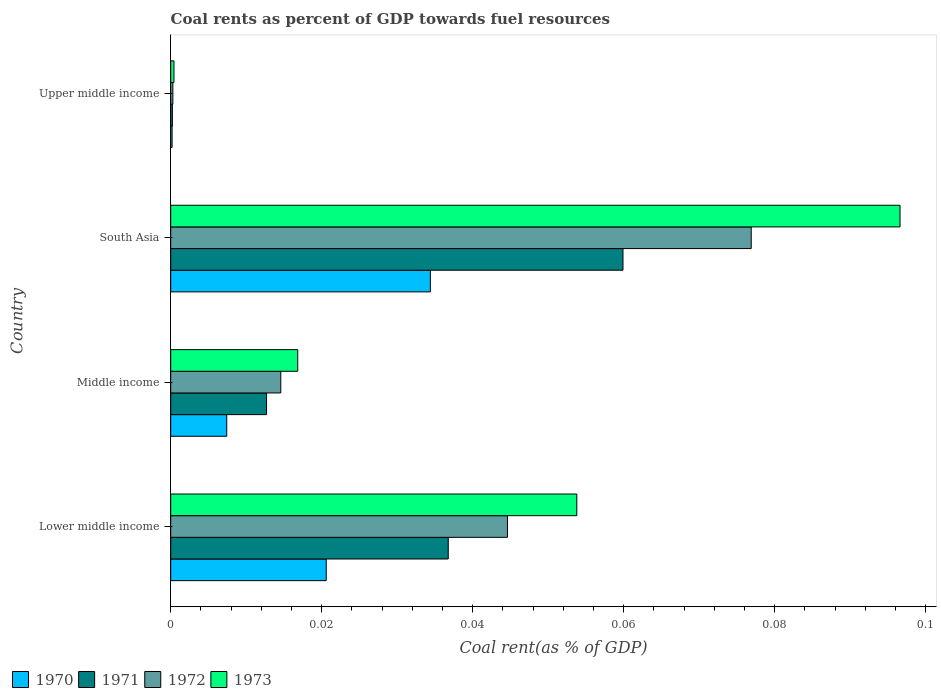How many different coloured bars are there?
Your answer should be compact. 4. What is the label of the 4th group of bars from the top?
Offer a terse response. Lower middle income. What is the coal rent in 1971 in Lower middle income?
Keep it short and to the point. 0.04. Across all countries, what is the maximum coal rent in 1971?
Your answer should be compact. 0.06. Across all countries, what is the minimum coal rent in 1971?
Ensure brevity in your answer.  0. In which country was the coal rent in 1970 minimum?
Give a very brief answer. Upper middle income. What is the total coal rent in 1973 in the graph?
Keep it short and to the point. 0.17. What is the difference between the coal rent in 1971 in Middle income and that in Upper middle income?
Offer a very short reply. 0.01. What is the difference between the coal rent in 1970 in Lower middle income and the coal rent in 1972 in Middle income?
Provide a short and direct response. 0.01. What is the average coal rent in 1972 per country?
Offer a very short reply. 0.03. What is the difference between the coal rent in 1973 and coal rent in 1971 in Middle income?
Offer a terse response. 0. What is the ratio of the coal rent in 1970 in Lower middle income to that in South Asia?
Give a very brief answer. 0.6. What is the difference between the highest and the second highest coal rent in 1972?
Give a very brief answer. 0.03. What is the difference between the highest and the lowest coal rent in 1970?
Provide a succinct answer. 0.03. In how many countries, is the coal rent in 1973 greater than the average coal rent in 1973 taken over all countries?
Give a very brief answer. 2. Is it the case that in every country, the sum of the coal rent in 1973 and coal rent in 1970 is greater than the sum of coal rent in 1971 and coal rent in 1972?
Offer a very short reply. No. What does the 2nd bar from the bottom in Lower middle income represents?
Offer a terse response. 1971. Are all the bars in the graph horizontal?
Your answer should be very brief. Yes. How many countries are there in the graph?
Make the answer very short. 4. Are the values on the major ticks of X-axis written in scientific E-notation?
Ensure brevity in your answer.  No. Does the graph contain any zero values?
Provide a short and direct response. No. Does the graph contain grids?
Keep it short and to the point. No. How many legend labels are there?
Make the answer very short. 4. What is the title of the graph?
Give a very brief answer. Coal rents as percent of GDP towards fuel resources. What is the label or title of the X-axis?
Make the answer very short. Coal rent(as % of GDP). What is the Coal rent(as % of GDP) of 1970 in Lower middle income?
Offer a very short reply. 0.02. What is the Coal rent(as % of GDP) in 1971 in Lower middle income?
Offer a very short reply. 0.04. What is the Coal rent(as % of GDP) in 1972 in Lower middle income?
Offer a terse response. 0.04. What is the Coal rent(as % of GDP) of 1973 in Lower middle income?
Your answer should be compact. 0.05. What is the Coal rent(as % of GDP) of 1970 in Middle income?
Give a very brief answer. 0.01. What is the Coal rent(as % of GDP) of 1971 in Middle income?
Provide a succinct answer. 0.01. What is the Coal rent(as % of GDP) in 1972 in Middle income?
Keep it short and to the point. 0.01. What is the Coal rent(as % of GDP) of 1973 in Middle income?
Ensure brevity in your answer.  0.02. What is the Coal rent(as % of GDP) of 1970 in South Asia?
Give a very brief answer. 0.03. What is the Coal rent(as % of GDP) in 1971 in South Asia?
Your response must be concise. 0.06. What is the Coal rent(as % of GDP) in 1972 in South Asia?
Offer a terse response. 0.08. What is the Coal rent(as % of GDP) in 1973 in South Asia?
Ensure brevity in your answer.  0.1. What is the Coal rent(as % of GDP) in 1970 in Upper middle income?
Ensure brevity in your answer.  0. What is the Coal rent(as % of GDP) of 1971 in Upper middle income?
Provide a short and direct response. 0. What is the Coal rent(as % of GDP) in 1972 in Upper middle income?
Provide a short and direct response. 0. What is the Coal rent(as % of GDP) in 1973 in Upper middle income?
Ensure brevity in your answer.  0. Across all countries, what is the maximum Coal rent(as % of GDP) in 1970?
Offer a terse response. 0.03. Across all countries, what is the maximum Coal rent(as % of GDP) in 1971?
Offer a very short reply. 0.06. Across all countries, what is the maximum Coal rent(as % of GDP) in 1972?
Make the answer very short. 0.08. Across all countries, what is the maximum Coal rent(as % of GDP) in 1973?
Provide a short and direct response. 0.1. Across all countries, what is the minimum Coal rent(as % of GDP) of 1970?
Your response must be concise. 0. Across all countries, what is the minimum Coal rent(as % of GDP) in 1971?
Provide a succinct answer. 0. Across all countries, what is the minimum Coal rent(as % of GDP) in 1972?
Your answer should be compact. 0. Across all countries, what is the minimum Coal rent(as % of GDP) in 1973?
Make the answer very short. 0. What is the total Coal rent(as % of GDP) of 1970 in the graph?
Offer a terse response. 0.06. What is the total Coal rent(as % of GDP) in 1971 in the graph?
Offer a terse response. 0.11. What is the total Coal rent(as % of GDP) of 1972 in the graph?
Offer a very short reply. 0.14. What is the total Coal rent(as % of GDP) of 1973 in the graph?
Give a very brief answer. 0.17. What is the difference between the Coal rent(as % of GDP) in 1970 in Lower middle income and that in Middle income?
Give a very brief answer. 0.01. What is the difference between the Coal rent(as % of GDP) in 1971 in Lower middle income and that in Middle income?
Offer a very short reply. 0.02. What is the difference between the Coal rent(as % of GDP) in 1973 in Lower middle income and that in Middle income?
Keep it short and to the point. 0.04. What is the difference between the Coal rent(as % of GDP) in 1970 in Lower middle income and that in South Asia?
Your answer should be compact. -0.01. What is the difference between the Coal rent(as % of GDP) in 1971 in Lower middle income and that in South Asia?
Ensure brevity in your answer.  -0.02. What is the difference between the Coal rent(as % of GDP) in 1972 in Lower middle income and that in South Asia?
Ensure brevity in your answer.  -0.03. What is the difference between the Coal rent(as % of GDP) in 1973 in Lower middle income and that in South Asia?
Offer a terse response. -0.04. What is the difference between the Coal rent(as % of GDP) of 1970 in Lower middle income and that in Upper middle income?
Your response must be concise. 0.02. What is the difference between the Coal rent(as % of GDP) of 1971 in Lower middle income and that in Upper middle income?
Keep it short and to the point. 0.04. What is the difference between the Coal rent(as % of GDP) of 1972 in Lower middle income and that in Upper middle income?
Offer a very short reply. 0.04. What is the difference between the Coal rent(as % of GDP) of 1973 in Lower middle income and that in Upper middle income?
Keep it short and to the point. 0.05. What is the difference between the Coal rent(as % of GDP) in 1970 in Middle income and that in South Asia?
Keep it short and to the point. -0.03. What is the difference between the Coal rent(as % of GDP) in 1971 in Middle income and that in South Asia?
Your response must be concise. -0.05. What is the difference between the Coal rent(as % of GDP) in 1972 in Middle income and that in South Asia?
Offer a terse response. -0.06. What is the difference between the Coal rent(as % of GDP) in 1973 in Middle income and that in South Asia?
Make the answer very short. -0.08. What is the difference between the Coal rent(as % of GDP) of 1970 in Middle income and that in Upper middle income?
Keep it short and to the point. 0.01. What is the difference between the Coal rent(as % of GDP) in 1971 in Middle income and that in Upper middle income?
Provide a succinct answer. 0.01. What is the difference between the Coal rent(as % of GDP) of 1972 in Middle income and that in Upper middle income?
Provide a short and direct response. 0.01. What is the difference between the Coal rent(as % of GDP) in 1973 in Middle income and that in Upper middle income?
Make the answer very short. 0.02. What is the difference between the Coal rent(as % of GDP) of 1970 in South Asia and that in Upper middle income?
Your answer should be very brief. 0.03. What is the difference between the Coal rent(as % of GDP) of 1971 in South Asia and that in Upper middle income?
Keep it short and to the point. 0.06. What is the difference between the Coal rent(as % of GDP) in 1972 in South Asia and that in Upper middle income?
Provide a short and direct response. 0.08. What is the difference between the Coal rent(as % of GDP) of 1973 in South Asia and that in Upper middle income?
Offer a very short reply. 0.1. What is the difference between the Coal rent(as % of GDP) in 1970 in Lower middle income and the Coal rent(as % of GDP) in 1971 in Middle income?
Offer a terse response. 0.01. What is the difference between the Coal rent(as % of GDP) of 1970 in Lower middle income and the Coal rent(as % of GDP) of 1972 in Middle income?
Your response must be concise. 0.01. What is the difference between the Coal rent(as % of GDP) of 1970 in Lower middle income and the Coal rent(as % of GDP) of 1973 in Middle income?
Give a very brief answer. 0. What is the difference between the Coal rent(as % of GDP) of 1971 in Lower middle income and the Coal rent(as % of GDP) of 1972 in Middle income?
Ensure brevity in your answer.  0.02. What is the difference between the Coal rent(as % of GDP) of 1971 in Lower middle income and the Coal rent(as % of GDP) of 1973 in Middle income?
Make the answer very short. 0.02. What is the difference between the Coal rent(as % of GDP) of 1972 in Lower middle income and the Coal rent(as % of GDP) of 1973 in Middle income?
Provide a short and direct response. 0.03. What is the difference between the Coal rent(as % of GDP) in 1970 in Lower middle income and the Coal rent(as % of GDP) in 1971 in South Asia?
Give a very brief answer. -0.04. What is the difference between the Coal rent(as % of GDP) of 1970 in Lower middle income and the Coal rent(as % of GDP) of 1972 in South Asia?
Your answer should be compact. -0.06. What is the difference between the Coal rent(as % of GDP) of 1970 in Lower middle income and the Coal rent(as % of GDP) of 1973 in South Asia?
Provide a short and direct response. -0.08. What is the difference between the Coal rent(as % of GDP) of 1971 in Lower middle income and the Coal rent(as % of GDP) of 1972 in South Asia?
Your answer should be very brief. -0.04. What is the difference between the Coal rent(as % of GDP) of 1971 in Lower middle income and the Coal rent(as % of GDP) of 1973 in South Asia?
Offer a terse response. -0.06. What is the difference between the Coal rent(as % of GDP) of 1972 in Lower middle income and the Coal rent(as % of GDP) of 1973 in South Asia?
Make the answer very short. -0.05. What is the difference between the Coal rent(as % of GDP) of 1970 in Lower middle income and the Coal rent(as % of GDP) of 1971 in Upper middle income?
Give a very brief answer. 0.02. What is the difference between the Coal rent(as % of GDP) of 1970 in Lower middle income and the Coal rent(as % of GDP) of 1972 in Upper middle income?
Ensure brevity in your answer.  0.02. What is the difference between the Coal rent(as % of GDP) in 1970 in Lower middle income and the Coal rent(as % of GDP) in 1973 in Upper middle income?
Ensure brevity in your answer.  0.02. What is the difference between the Coal rent(as % of GDP) in 1971 in Lower middle income and the Coal rent(as % of GDP) in 1972 in Upper middle income?
Give a very brief answer. 0.04. What is the difference between the Coal rent(as % of GDP) of 1971 in Lower middle income and the Coal rent(as % of GDP) of 1973 in Upper middle income?
Your answer should be compact. 0.04. What is the difference between the Coal rent(as % of GDP) of 1972 in Lower middle income and the Coal rent(as % of GDP) of 1973 in Upper middle income?
Offer a terse response. 0.04. What is the difference between the Coal rent(as % of GDP) in 1970 in Middle income and the Coal rent(as % of GDP) in 1971 in South Asia?
Offer a terse response. -0.05. What is the difference between the Coal rent(as % of GDP) of 1970 in Middle income and the Coal rent(as % of GDP) of 1972 in South Asia?
Provide a succinct answer. -0.07. What is the difference between the Coal rent(as % of GDP) in 1970 in Middle income and the Coal rent(as % of GDP) in 1973 in South Asia?
Give a very brief answer. -0.09. What is the difference between the Coal rent(as % of GDP) in 1971 in Middle income and the Coal rent(as % of GDP) in 1972 in South Asia?
Give a very brief answer. -0.06. What is the difference between the Coal rent(as % of GDP) in 1971 in Middle income and the Coal rent(as % of GDP) in 1973 in South Asia?
Your response must be concise. -0.08. What is the difference between the Coal rent(as % of GDP) in 1972 in Middle income and the Coal rent(as % of GDP) in 1973 in South Asia?
Your response must be concise. -0.08. What is the difference between the Coal rent(as % of GDP) of 1970 in Middle income and the Coal rent(as % of GDP) of 1971 in Upper middle income?
Ensure brevity in your answer.  0.01. What is the difference between the Coal rent(as % of GDP) in 1970 in Middle income and the Coal rent(as % of GDP) in 1972 in Upper middle income?
Keep it short and to the point. 0.01. What is the difference between the Coal rent(as % of GDP) of 1970 in Middle income and the Coal rent(as % of GDP) of 1973 in Upper middle income?
Offer a terse response. 0.01. What is the difference between the Coal rent(as % of GDP) of 1971 in Middle income and the Coal rent(as % of GDP) of 1972 in Upper middle income?
Ensure brevity in your answer.  0.01. What is the difference between the Coal rent(as % of GDP) of 1971 in Middle income and the Coal rent(as % of GDP) of 1973 in Upper middle income?
Offer a very short reply. 0.01. What is the difference between the Coal rent(as % of GDP) of 1972 in Middle income and the Coal rent(as % of GDP) of 1973 in Upper middle income?
Give a very brief answer. 0.01. What is the difference between the Coal rent(as % of GDP) in 1970 in South Asia and the Coal rent(as % of GDP) in 1971 in Upper middle income?
Offer a very short reply. 0.03. What is the difference between the Coal rent(as % of GDP) of 1970 in South Asia and the Coal rent(as % of GDP) of 1972 in Upper middle income?
Your answer should be compact. 0.03. What is the difference between the Coal rent(as % of GDP) in 1970 in South Asia and the Coal rent(as % of GDP) in 1973 in Upper middle income?
Your answer should be compact. 0.03. What is the difference between the Coal rent(as % of GDP) of 1971 in South Asia and the Coal rent(as % of GDP) of 1972 in Upper middle income?
Provide a short and direct response. 0.06. What is the difference between the Coal rent(as % of GDP) of 1971 in South Asia and the Coal rent(as % of GDP) of 1973 in Upper middle income?
Provide a short and direct response. 0.06. What is the difference between the Coal rent(as % of GDP) in 1972 in South Asia and the Coal rent(as % of GDP) in 1973 in Upper middle income?
Offer a terse response. 0.08. What is the average Coal rent(as % of GDP) in 1970 per country?
Your answer should be very brief. 0.02. What is the average Coal rent(as % of GDP) in 1971 per country?
Offer a terse response. 0.03. What is the average Coal rent(as % of GDP) in 1972 per country?
Keep it short and to the point. 0.03. What is the average Coal rent(as % of GDP) in 1973 per country?
Keep it short and to the point. 0.04. What is the difference between the Coal rent(as % of GDP) of 1970 and Coal rent(as % of GDP) of 1971 in Lower middle income?
Offer a terse response. -0.02. What is the difference between the Coal rent(as % of GDP) of 1970 and Coal rent(as % of GDP) of 1972 in Lower middle income?
Make the answer very short. -0.02. What is the difference between the Coal rent(as % of GDP) of 1970 and Coal rent(as % of GDP) of 1973 in Lower middle income?
Provide a succinct answer. -0.03. What is the difference between the Coal rent(as % of GDP) in 1971 and Coal rent(as % of GDP) in 1972 in Lower middle income?
Offer a very short reply. -0.01. What is the difference between the Coal rent(as % of GDP) in 1971 and Coal rent(as % of GDP) in 1973 in Lower middle income?
Keep it short and to the point. -0.02. What is the difference between the Coal rent(as % of GDP) of 1972 and Coal rent(as % of GDP) of 1973 in Lower middle income?
Make the answer very short. -0.01. What is the difference between the Coal rent(as % of GDP) in 1970 and Coal rent(as % of GDP) in 1971 in Middle income?
Your answer should be compact. -0.01. What is the difference between the Coal rent(as % of GDP) of 1970 and Coal rent(as % of GDP) of 1972 in Middle income?
Give a very brief answer. -0.01. What is the difference between the Coal rent(as % of GDP) in 1970 and Coal rent(as % of GDP) in 1973 in Middle income?
Make the answer very short. -0.01. What is the difference between the Coal rent(as % of GDP) in 1971 and Coal rent(as % of GDP) in 1972 in Middle income?
Provide a succinct answer. -0. What is the difference between the Coal rent(as % of GDP) in 1971 and Coal rent(as % of GDP) in 1973 in Middle income?
Provide a succinct answer. -0. What is the difference between the Coal rent(as % of GDP) of 1972 and Coal rent(as % of GDP) of 1973 in Middle income?
Provide a short and direct response. -0. What is the difference between the Coal rent(as % of GDP) of 1970 and Coal rent(as % of GDP) of 1971 in South Asia?
Offer a terse response. -0.03. What is the difference between the Coal rent(as % of GDP) in 1970 and Coal rent(as % of GDP) in 1972 in South Asia?
Your answer should be very brief. -0.04. What is the difference between the Coal rent(as % of GDP) in 1970 and Coal rent(as % of GDP) in 1973 in South Asia?
Offer a very short reply. -0.06. What is the difference between the Coal rent(as % of GDP) of 1971 and Coal rent(as % of GDP) of 1972 in South Asia?
Your answer should be compact. -0.02. What is the difference between the Coal rent(as % of GDP) in 1971 and Coal rent(as % of GDP) in 1973 in South Asia?
Ensure brevity in your answer.  -0.04. What is the difference between the Coal rent(as % of GDP) of 1972 and Coal rent(as % of GDP) of 1973 in South Asia?
Give a very brief answer. -0.02. What is the difference between the Coal rent(as % of GDP) of 1970 and Coal rent(as % of GDP) of 1971 in Upper middle income?
Your answer should be very brief. -0. What is the difference between the Coal rent(as % of GDP) in 1970 and Coal rent(as % of GDP) in 1972 in Upper middle income?
Give a very brief answer. -0. What is the difference between the Coal rent(as % of GDP) of 1970 and Coal rent(as % of GDP) of 1973 in Upper middle income?
Offer a very short reply. -0. What is the difference between the Coal rent(as % of GDP) of 1971 and Coal rent(as % of GDP) of 1972 in Upper middle income?
Give a very brief answer. -0. What is the difference between the Coal rent(as % of GDP) of 1971 and Coal rent(as % of GDP) of 1973 in Upper middle income?
Ensure brevity in your answer.  -0. What is the difference between the Coal rent(as % of GDP) in 1972 and Coal rent(as % of GDP) in 1973 in Upper middle income?
Your response must be concise. -0. What is the ratio of the Coal rent(as % of GDP) in 1970 in Lower middle income to that in Middle income?
Your answer should be very brief. 2.78. What is the ratio of the Coal rent(as % of GDP) of 1971 in Lower middle income to that in Middle income?
Your response must be concise. 2.9. What is the ratio of the Coal rent(as % of GDP) of 1972 in Lower middle income to that in Middle income?
Provide a short and direct response. 3.06. What is the ratio of the Coal rent(as % of GDP) in 1973 in Lower middle income to that in Middle income?
Offer a very short reply. 3.2. What is the ratio of the Coal rent(as % of GDP) of 1970 in Lower middle income to that in South Asia?
Ensure brevity in your answer.  0.6. What is the ratio of the Coal rent(as % of GDP) of 1971 in Lower middle income to that in South Asia?
Offer a very short reply. 0.61. What is the ratio of the Coal rent(as % of GDP) of 1972 in Lower middle income to that in South Asia?
Your answer should be very brief. 0.58. What is the ratio of the Coal rent(as % of GDP) in 1973 in Lower middle income to that in South Asia?
Provide a succinct answer. 0.56. What is the ratio of the Coal rent(as % of GDP) of 1970 in Lower middle income to that in Upper middle income?
Make the answer very short. 112.03. What is the ratio of the Coal rent(as % of GDP) of 1971 in Lower middle income to that in Upper middle income?
Your response must be concise. 167.98. What is the ratio of the Coal rent(as % of GDP) of 1972 in Lower middle income to that in Upper middle income?
Give a very brief answer. 156.82. What is the ratio of the Coal rent(as % of GDP) in 1973 in Lower middle income to that in Upper middle income?
Offer a terse response. 124.82. What is the ratio of the Coal rent(as % of GDP) of 1970 in Middle income to that in South Asia?
Your answer should be very brief. 0.22. What is the ratio of the Coal rent(as % of GDP) in 1971 in Middle income to that in South Asia?
Your answer should be very brief. 0.21. What is the ratio of the Coal rent(as % of GDP) of 1972 in Middle income to that in South Asia?
Keep it short and to the point. 0.19. What is the ratio of the Coal rent(as % of GDP) in 1973 in Middle income to that in South Asia?
Give a very brief answer. 0.17. What is the ratio of the Coal rent(as % of GDP) in 1970 in Middle income to that in Upper middle income?
Provide a short and direct response. 40.36. What is the ratio of the Coal rent(as % of GDP) of 1971 in Middle income to that in Upper middle income?
Give a very brief answer. 58.01. What is the ratio of the Coal rent(as % of GDP) in 1972 in Middle income to that in Upper middle income?
Your answer should be very brief. 51.25. What is the ratio of the Coal rent(as % of GDP) of 1973 in Middle income to that in Upper middle income?
Ensure brevity in your answer.  39.04. What is the ratio of the Coal rent(as % of GDP) in 1970 in South Asia to that in Upper middle income?
Provide a short and direct response. 187.05. What is the ratio of the Coal rent(as % of GDP) of 1971 in South Asia to that in Upper middle income?
Ensure brevity in your answer.  273.74. What is the ratio of the Coal rent(as % of GDP) in 1972 in South Asia to that in Upper middle income?
Your response must be concise. 270.32. What is the ratio of the Coal rent(as % of GDP) in 1973 in South Asia to that in Upper middle income?
Ensure brevity in your answer.  224.18. What is the difference between the highest and the second highest Coal rent(as % of GDP) in 1970?
Provide a short and direct response. 0.01. What is the difference between the highest and the second highest Coal rent(as % of GDP) in 1971?
Offer a terse response. 0.02. What is the difference between the highest and the second highest Coal rent(as % of GDP) in 1972?
Your response must be concise. 0.03. What is the difference between the highest and the second highest Coal rent(as % of GDP) in 1973?
Your answer should be very brief. 0.04. What is the difference between the highest and the lowest Coal rent(as % of GDP) of 1970?
Offer a terse response. 0.03. What is the difference between the highest and the lowest Coal rent(as % of GDP) in 1971?
Ensure brevity in your answer.  0.06. What is the difference between the highest and the lowest Coal rent(as % of GDP) of 1972?
Your answer should be very brief. 0.08. What is the difference between the highest and the lowest Coal rent(as % of GDP) in 1973?
Offer a terse response. 0.1. 